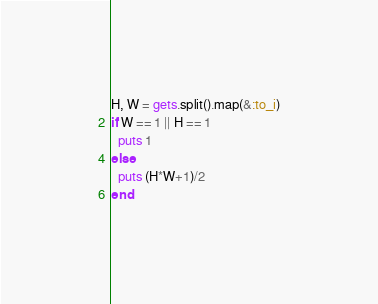<code> <loc_0><loc_0><loc_500><loc_500><_Ruby_>H, W = gets.split().map(&:to_i)
if W == 1 || H == 1
  puts 1
else
  puts (H*W+1)/2
end</code> 